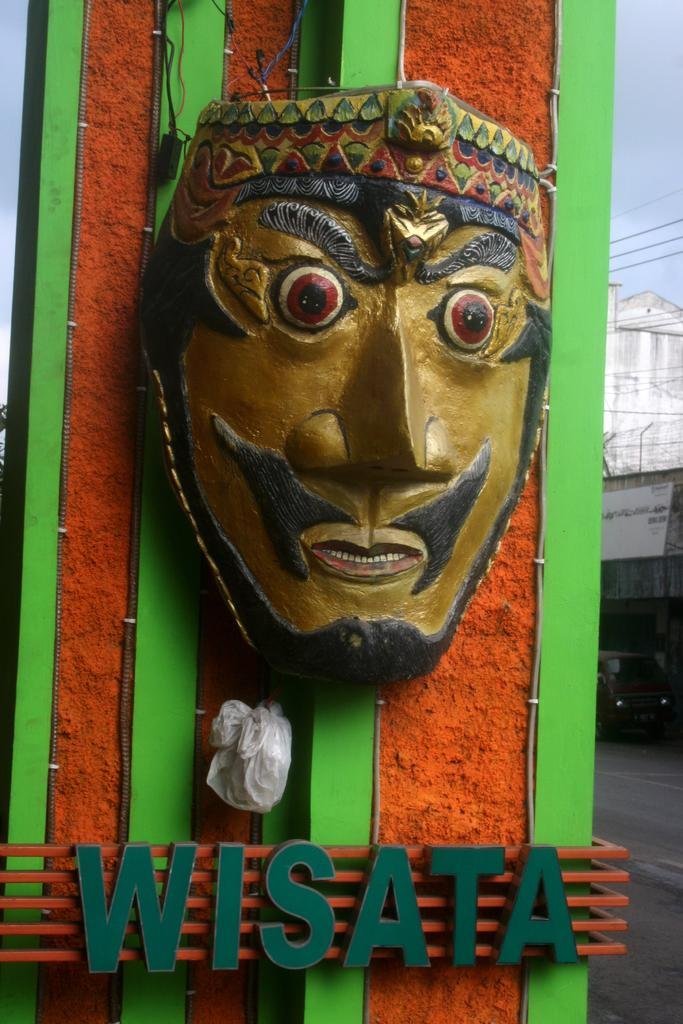What is the main object in the image? There is a mask in the image. What else can be seen in the image besides the mask? There is text, cables, and objects on the wall in the image. What can be seen in the background of the image? There are clouds in the sky, electric wires, a building, and other objects in the background of the image. What type of humor can be seen in the image? There is no humor present in the image; it features a mask, text, cables, objects on the wall, and a background with clouds, electric wires, a building, and other objects. What is the border of the image made of? The border of the image is not visible or mentioned in the provided facts, so it cannot be determined. 